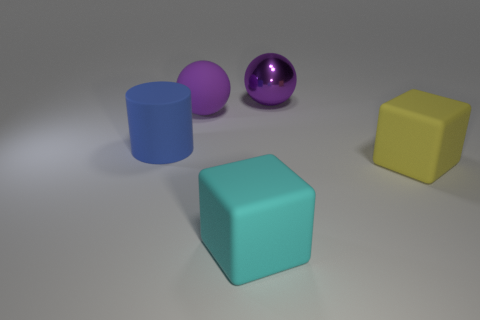Add 2 purple metallic balls. How many objects exist? 7 Subtract 0 gray balls. How many objects are left? 5 Subtract all blocks. How many objects are left? 3 Subtract all big purple shiny cylinders. Subtract all large purple metallic spheres. How many objects are left? 4 Add 4 yellow objects. How many yellow objects are left? 5 Add 1 large purple rubber balls. How many large purple rubber balls exist? 2 